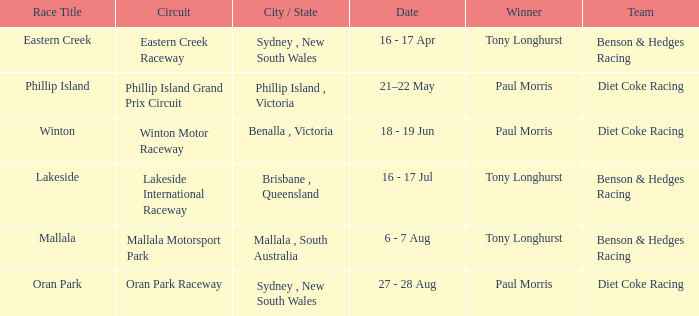What was the name of the driver that won the Lakeside race? Tony Longhurst. 